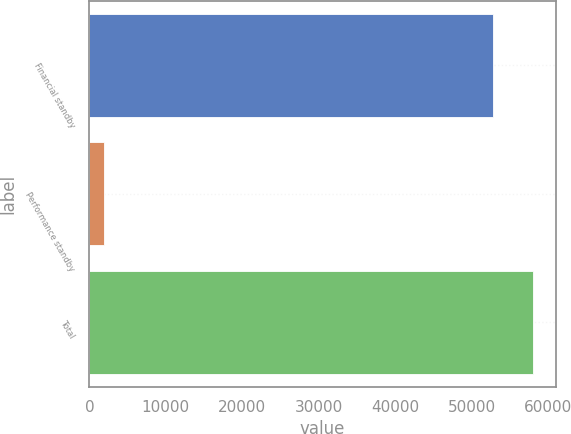<chart> <loc_0><loc_0><loc_500><loc_500><bar_chart><fcel>Financial standby<fcel>Performance standby<fcel>Total<nl><fcel>52814<fcel>1851<fcel>58095.4<nl></chart> 